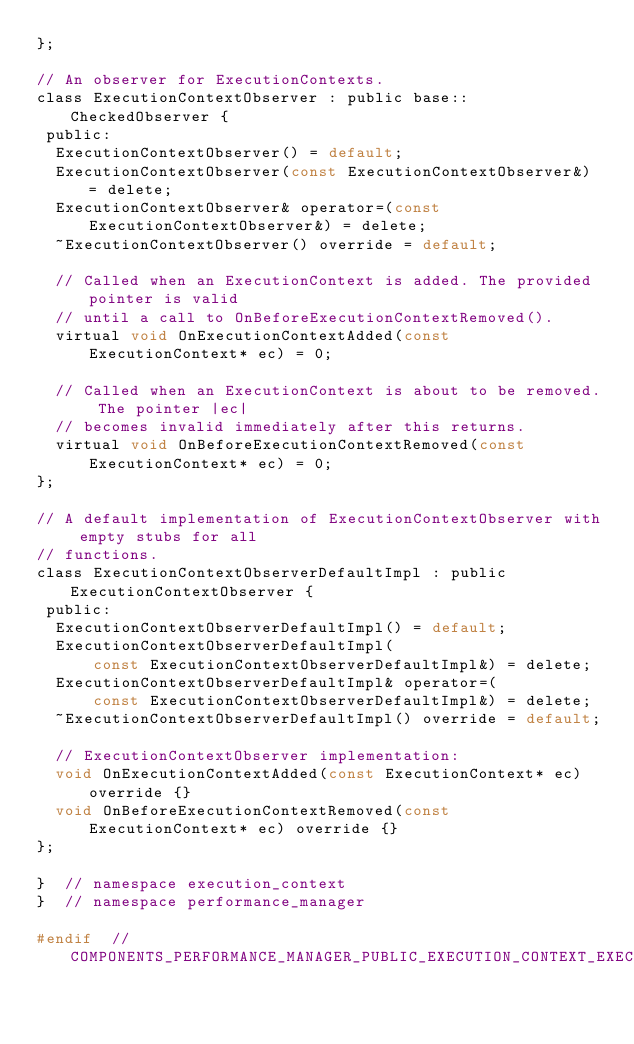Convert code to text. <code><loc_0><loc_0><loc_500><loc_500><_C_>};

// An observer for ExecutionContexts.
class ExecutionContextObserver : public base::CheckedObserver {
 public:
  ExecutionContextObserver() = default;
  ExecutionContextObserver(const ExecutionContextObserver&) = delete;
  ExecutionContextObserver& operator=(const ExecutionContextObserver&) = delete;
  ~ExecutionContextObserver() override = default;

  // Called when an ExecutionContext is added. The provided pointer is valid
  // until a call to OnBeforeExecutionContextRemoved().
  virtual void OnExecutionContextAdded(const ExecutionContext* ec) = 0;

  // Called when an ExecutionContext is about to be removed. The pointer |ec|
  // becomes invalid immediately after this returns.
  virtual void OnBeforeExecutionContextRemoved(const ExecutionContext* ec) = 0;
};

// A default implementation of ExecutionContextObserver with empty stubs for all
// functions.
class ExecutionContextObserverDefaultImpl : public ExecutionContextObserver {
 public:
  ExecutionContextObserverDefaultImpl() = default;
  ExecutionContextObserverDefaultImpl(
      const ExecutionContextObserverDefaultImpl&) = delete;
  ExecutionContextObserverDefaultImpl& operator=(
      const ExecutionContextObserverDefaultImpl&) = delete;
  ~ExecutionContextObserverDefaultImpl() override = default;

  // ExecutionContextObserver implementation:
  void OnExecutionContextAdded(const ExecutionContext* ec) override {}
  void OnBeforeExecutionContextRemoved(const ExecutionContext* ec) override {}
};

}  // namespace execution_context
}  // namespace performance_manager

#endif  // COMPONENTS_PERFORMANCE_MANAGER_PUBLIC_EXECUTION_CONTEXT_EXECUTION_CONTEXT_H_</code> 